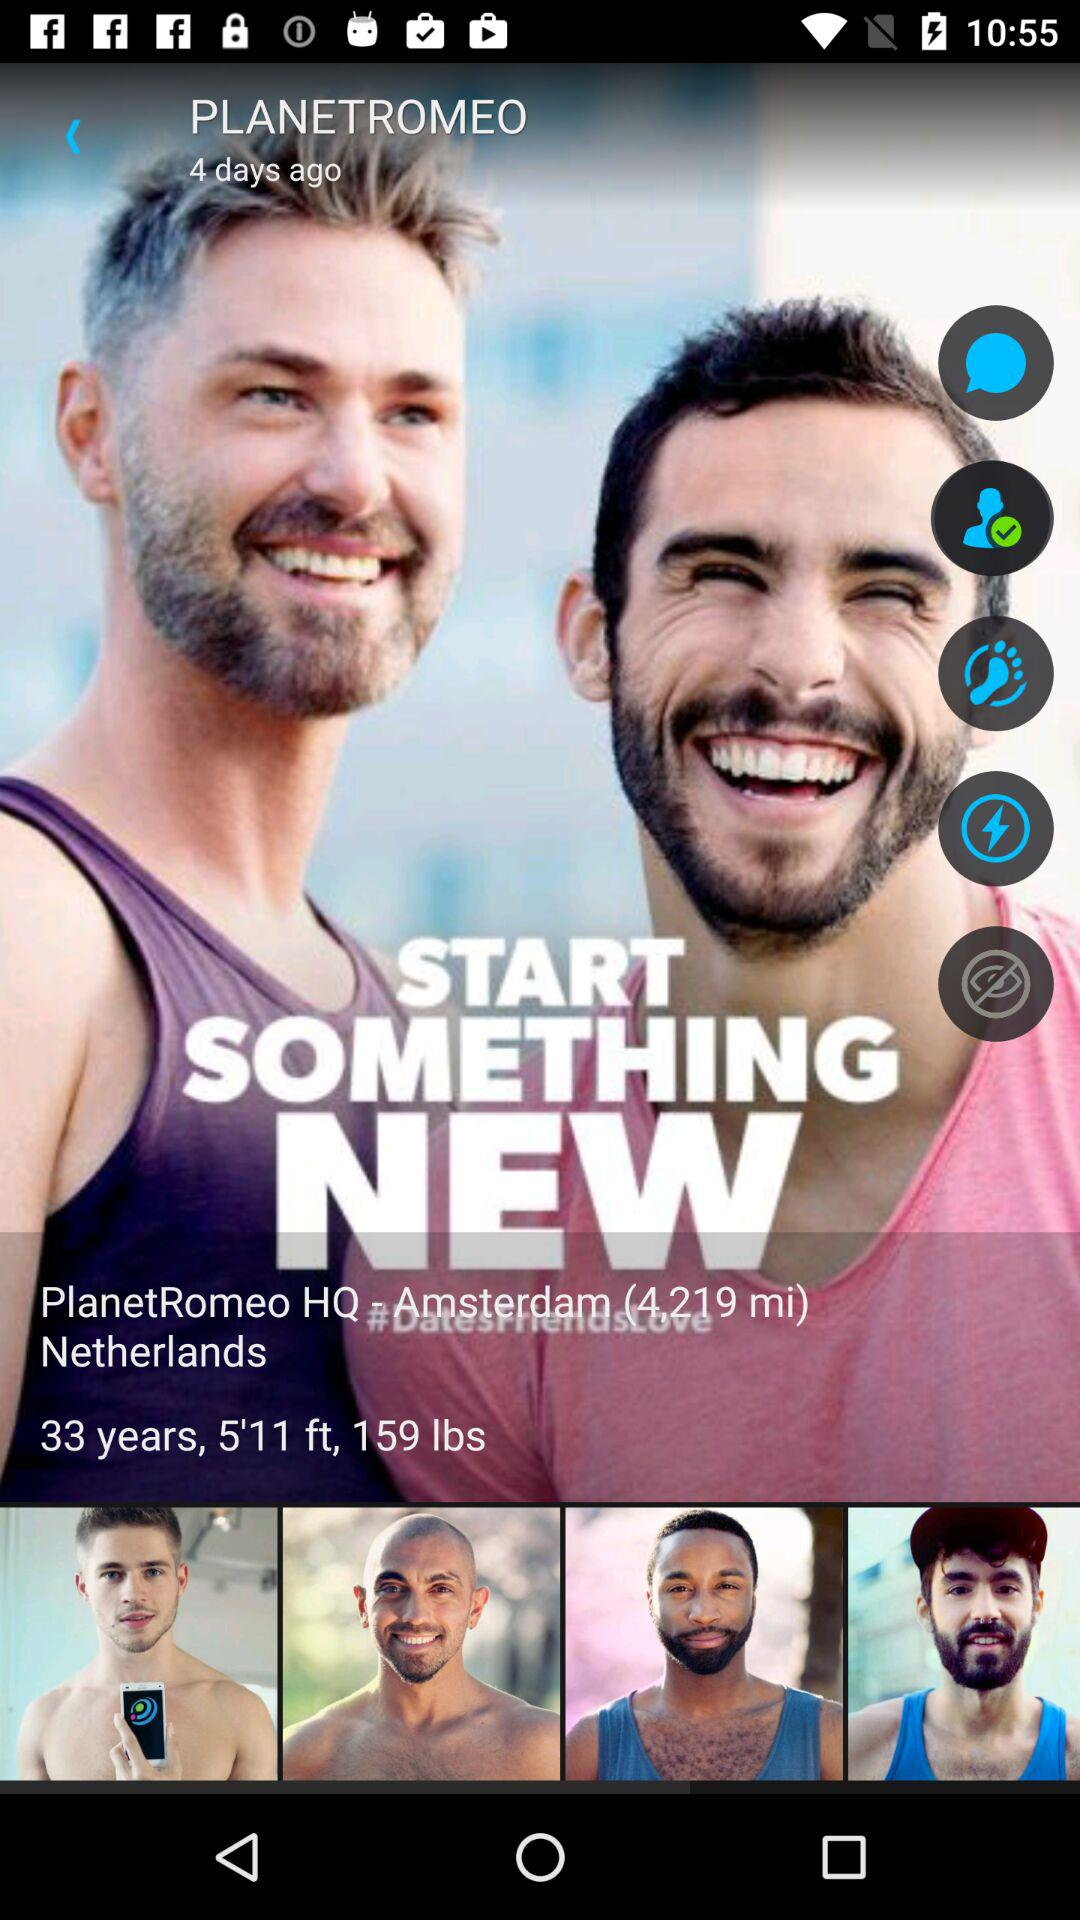What is the age of PlanetRomeo? PlanetRomeo is 33 years old. 